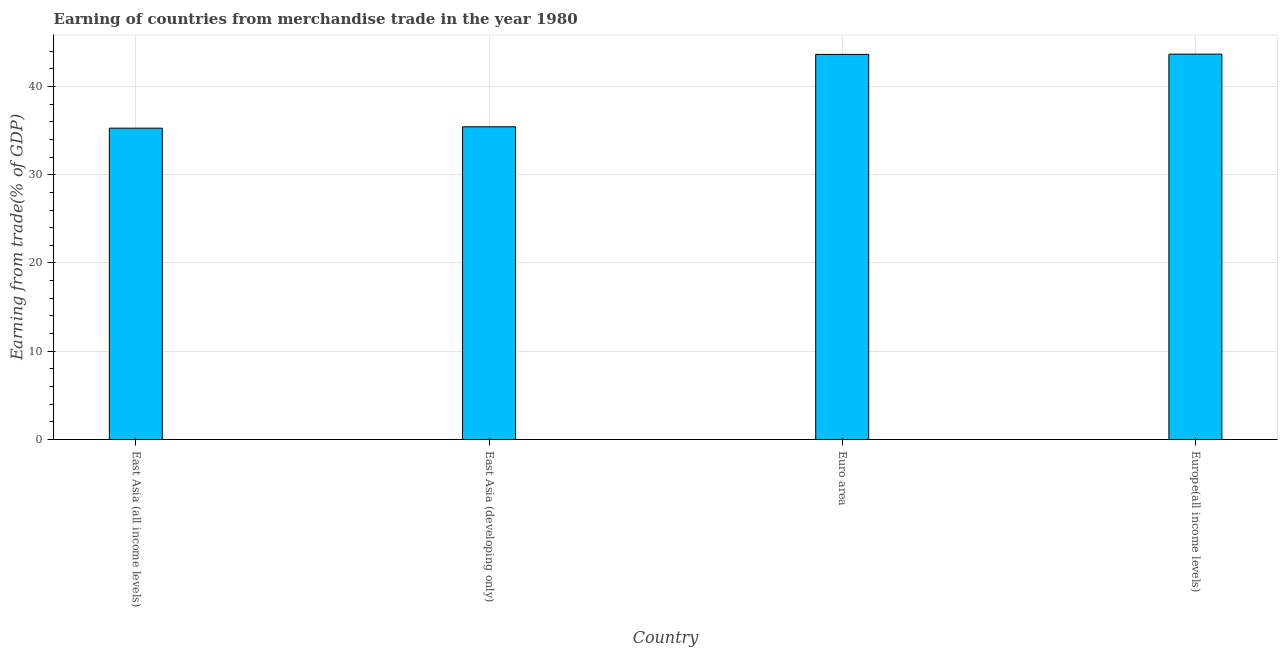Does the graph contain any zero values?
Provide a succinct answer. No. What is the title of the graph?
Your answer should be very brief. Earning of countries from merchandise trade in the year 1980. What is the label or title of the X-axis?
Make the answer very short. Country. What is the label or title of the Y-axis?
Make the answer very short. Earning from trade(% of GDP). What is the earning from merchandise trade in East Asia (developing only)?
Make the answer very short. 35.43. Across all countries, what is the maximum earning from merchandise trade?
Offer a very short reply. 43.66. Across all countries, what is the minimum earning from merchandise trade?
Give a very brief answer. 35.27. In which country was the earning from merchandise trade maximum?
Keep it short and to the point. Europe(all income levels). In which country was the earning from merchandise trade minimum?
Your answer should be very brief. East Asia (all income levels). What is the sum of the earning from merchandise trade?
Provide a succinct answer. 157.99. What is the difference between the earning from merchandise trade in Euro area and Europe(all income levels)?
Offer a very short reply. -0.03. What is the average earning from merchandise trade per country?
Make the answer very short. 39.5. What is the median earning from merchandise trade?
Ensure brevity in your answer.  39.53. Is the earning from merchandise trade in East Asia (developing only) less than that in Europe(all income levels)?
Keep it short and to the point. Yes. What is the difference between the highest and the second highest earning from merchandise trade?
Keep it short and to the point. 0.03. Is the sum of the earning from merchandise trade in East Asia (all income levels) and East Asia (developing only) greater than the maximum earning from merchandise trade across all countries?
Provide a succinct answer. Yes. What is the difference between the highest and the lowest earning from merchandise trade?
Your response must be concise. 8.39. How many countries are there in the graph?
Offer a terse response. 4. Are the values on the major ticks of Y-axis written in scientific E-notation?
Offer a terse response. No. What is the Earning from trade(% of GDP) in East Asia (all income levels)?
Ensure brevity in your answer.  35.27. What is the Earning from trade(% of GDP) in East Asia (developing only)?
Give a very brief answer. 35.43. What is the Earning from trade(% of GDP) of Euro area?
Your answer should be very brief. 43.63. What is the Earning from trade(% of GDP) in Europe(all income levels)?
Provide a short and direct response. 43.66. What is the difference between the Earning from trade(% of GDP) in East Asia (all income levels) and East Asia (developing only)?
Your answer should be very brief. -0.15. What is the difference between the Earning from trade(% of GDP) in East Asia (all income levels) and Euro area?
Provide a short and direct response. -8.36. What is the difference between the Earning from trade(% of GDP) in East Asia (all income levels) and Europe(all income levels)?
Ensure brevity in your answer.  -8.39. What is the difference between the Earning from trade(% of GDP) in East Asia (developing only) and Euro area?
Your answer should be compact. -8.2. What is the difference between the Earning from trade(% of GDP) in East Asia (developing only) and Europe(all income levels)?
Ensure brevity in your answer.  -8.23. What is the difference between the Earning from trade(% of GDP) in Euro area and Europe(all income levels)?
Provide a succinct answer. -0.03. What is the ratio of the Earning from trade(% of GDP) in East Asia (all income levels) to that in Euro area?
Your answer should be very brief. 0.81. What is the ratio of the Earning from trade(% of GDP) in East Asia (all income levels) to that in Europe(all income levels)?
Offer a very short reply. 0.81. What is the ratio of the Earning from trade(% of GDP) in East Asia (developing only) to that in Euro area?
Your response must be concise. 0.81. What is the ratio of the Earning from trade(% of GDP) in East Asia (developing only) to that in Europe(all income levels)?
Make the answer very short. 0.81. 